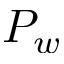Convert formula to latex. <formula><loc_0><loc_0><loc_500><loc_500>P _ { w }</formula> 